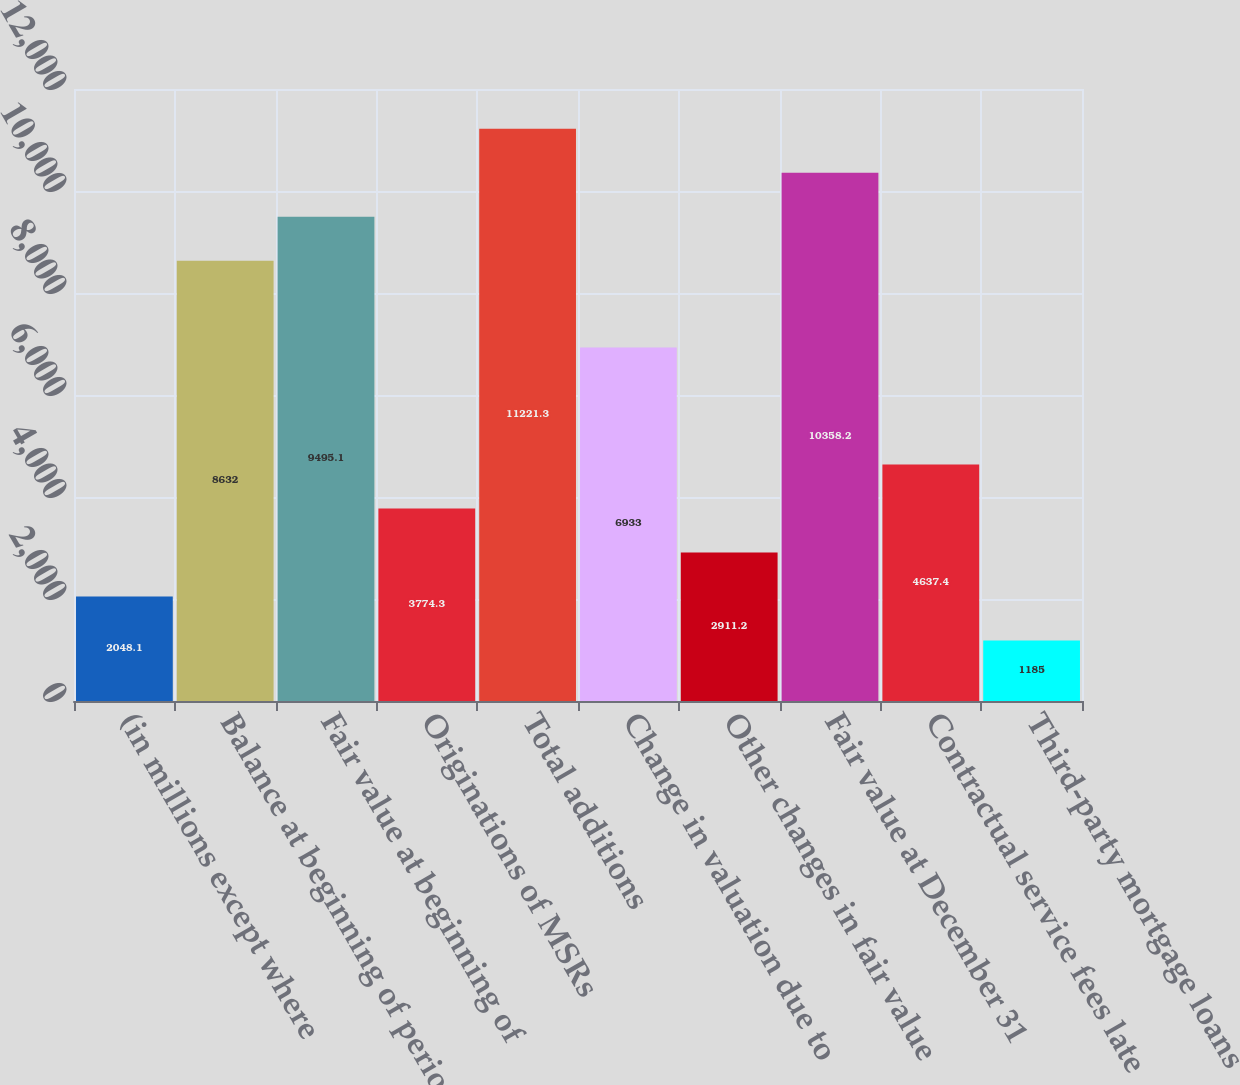Convert chart to OTSL. <chart><loc_0><loc_0><loc_500><loc_500><bar_chart><fcel>(in millions except where<fcel>Balance at beginning of period<fcel>Fair value at beginning of<fcel>Originations of MSRs<fcel>Total additions<fcel>Change in valuation due to<fcel>Other changes in fair value<fcel>Fair value at December 31<fcel>Contractual service fees late<fcel>Third-party mortgage loans<nl><fcel>2048.1<fcel>8632<fcel>9495.1<fcel>3774.3<fcel>11221.3<fcel>6933<fcel>2911.2<fcel>10358.2<fcel>4637.4<fcel>1185<nl></chart> 